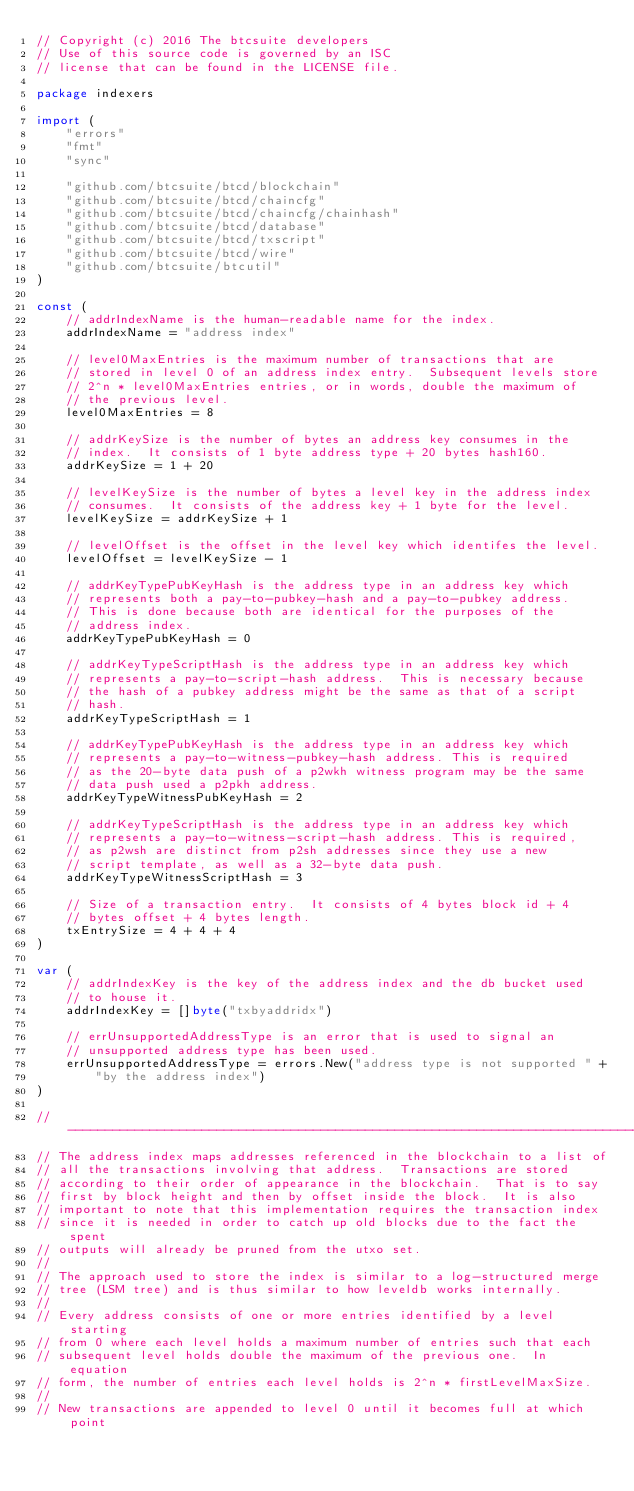<code> <loc_0><loc_0><loc_500><loc_500><_Go_>// Copyright (c) 2016 The btcsuite developers
// Use of this source code is governed by an ISC
// license that can be found in the LICENSE file.

package indexers

import (
	"errors"
	"fmt"
	"sync"

	"github.com/btcsuite/btcd/blockchain"
	"github.com/btcsuite/btcd/chaincfg"
	"github.com/btcsuite/btcd/chaincfg/chainhash"
	"github.com/btcsuite/btcd/database"
	"github.com/btcsuite/btcd/txscript"
	"github.com/btcsuite/btcd/wire"
	"github.com/btcsuite/btcutil"
)

const (
	// addrIndexName is the human-readable name for the index.
	addrIndexName = "address index"

	// level0MaxEntries is the maximum number of transactions that are
	// stored in level 0 of an address index entry.  Subsequent levels store
	// 2^n * level0MaxEntries entries, or in words, double the maximum of
	// the previous level.
	level0MaxEntries = 8

	// addrKeySize is the number of bytes an address key consumes in the
	// index.  It consists of 1 byte address type + 20 bytes hash160.
	addrKeySize = 1 + 20

	// levelKeySize is the number of bytes a level key in the address index
	// consumes.  It consists of the address key + 1 byte for the level.
	levelKeySize = addrKeySize + 1

	// levelOffset is the offset in the level key which identifes the level.
	levelOffset = levelKeySize - 1

	// addrKeyTypePubKeyHash is the address type in an address key which
	// represents both a pay-to-pubkey-hash and a pay-to-pubkey address.
	// This is done because both are identical for the purposes of the
	// address index.
	addrKeyTypePubKeyHash = 0

	// addrKeyTypeScriptHash is the address type in an address key which
	// represents a pay-to-script-hash address.  This is necessary because
	// the hash of a pubkey address might be the same as that of a script
	// hash.
	addrKeyTypeScriptHash = 1

	// addrKeyTypePubKeyHash is the address type in an address key which
	// represents a pay-to-witness-pubkey-hash address. This is required
	// as the 20-byte data push of a p2wkh witness program may be the same
	// data push used a p2pkh address.
	addrKeyTypeWitnessPubKeyHash = 2

	// addrKeyTypeScriptHash is the address type in an address key which
	// represents a pay-to-witness-script-hash address. This is required,
	// as p2wsh are distinct from p2sh addresses since they use a new
	// script template, as well as a 32-byte data push.
	addrKeyTypeWitnessScriptHash = 3

	// Size of a transaction entry.  It consists of 4 bytes block id + 4
	// bytes offset + 4 bytes length.
	txEntrySize = 4 + 4 + 4
)

var (
	// addrIndexKey is the key of the address index and the db bucket used
	// to house it.
	addrIndexKey = []byte("txbyaddridx")

	// errUnsupportedAddressType is an error that is used to signal an
	// unsupported address type has been used.
	errUnsupportedAddressType = errors.New("address type is not supported " +
		"by the address index")
)

// -----------------------------------------------------------------------------
// The address index maps addresses referenced in the blockchain to a list of
// all the transactions involving that address.  Transactions are stored
// according to their order of appearance in the blockchain.  That is to say
// first by block height and then by offset inside the block.  It is also
// important to note that this implementation requires the transaction index
// since it is needed in order to catch up old blocks due to the fact the spent
// outputs will already be pruned from the utxo set.
//
// The approach used to store the index is similar to a log-structured merge
// tree (LSM tree) and is thus similar to how leveldb works internally.
//
// Every address consists of one or more entries identified by a level starting
// from 0 where each level holds a maximum number of entries such that each
// subsequent level holds double the maximum of the previous one.  In equation
// form, the number of entries each level holds is 2^n * firstLevelMaxSize.
//
// New transactions are appended to level 0 until it becomes full at which point</code> 